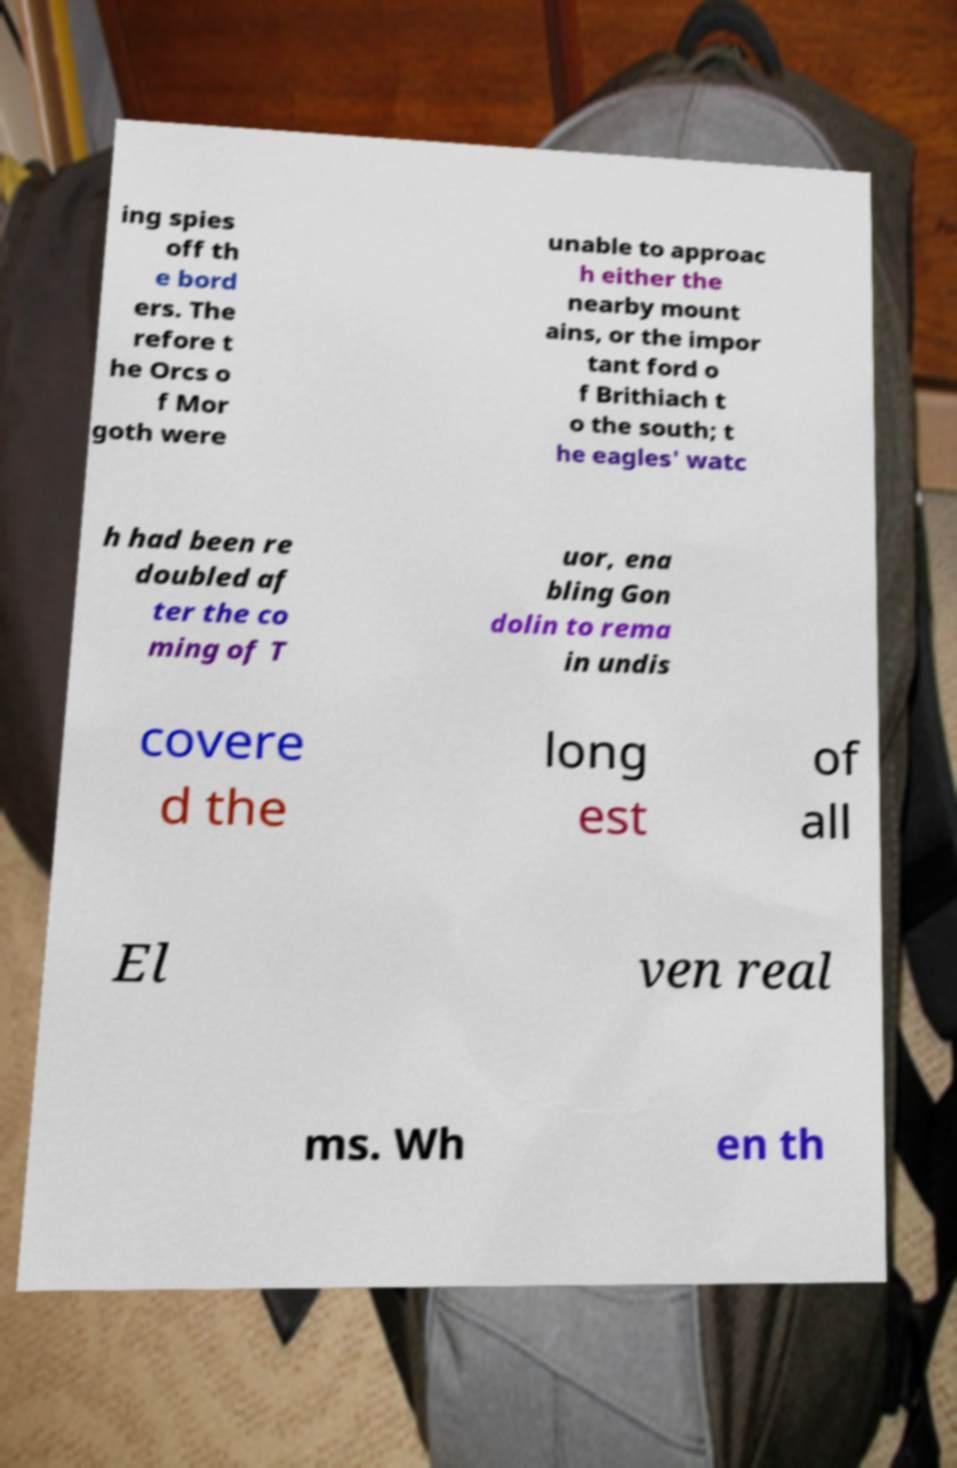Could you extract and type out the text from this image? ing spies off th e bord ers. The refore t he Orcs o f Mor goth were unable to approac h either the nearby mount ains, or the impor tant ford o f Brithiach t o the south; t he eagles' watc h had been re doubled af ter the co ming of T uor, ena bling Gon dolin to rema in undis covere d the long est of all El ven real ms. Wh en th 